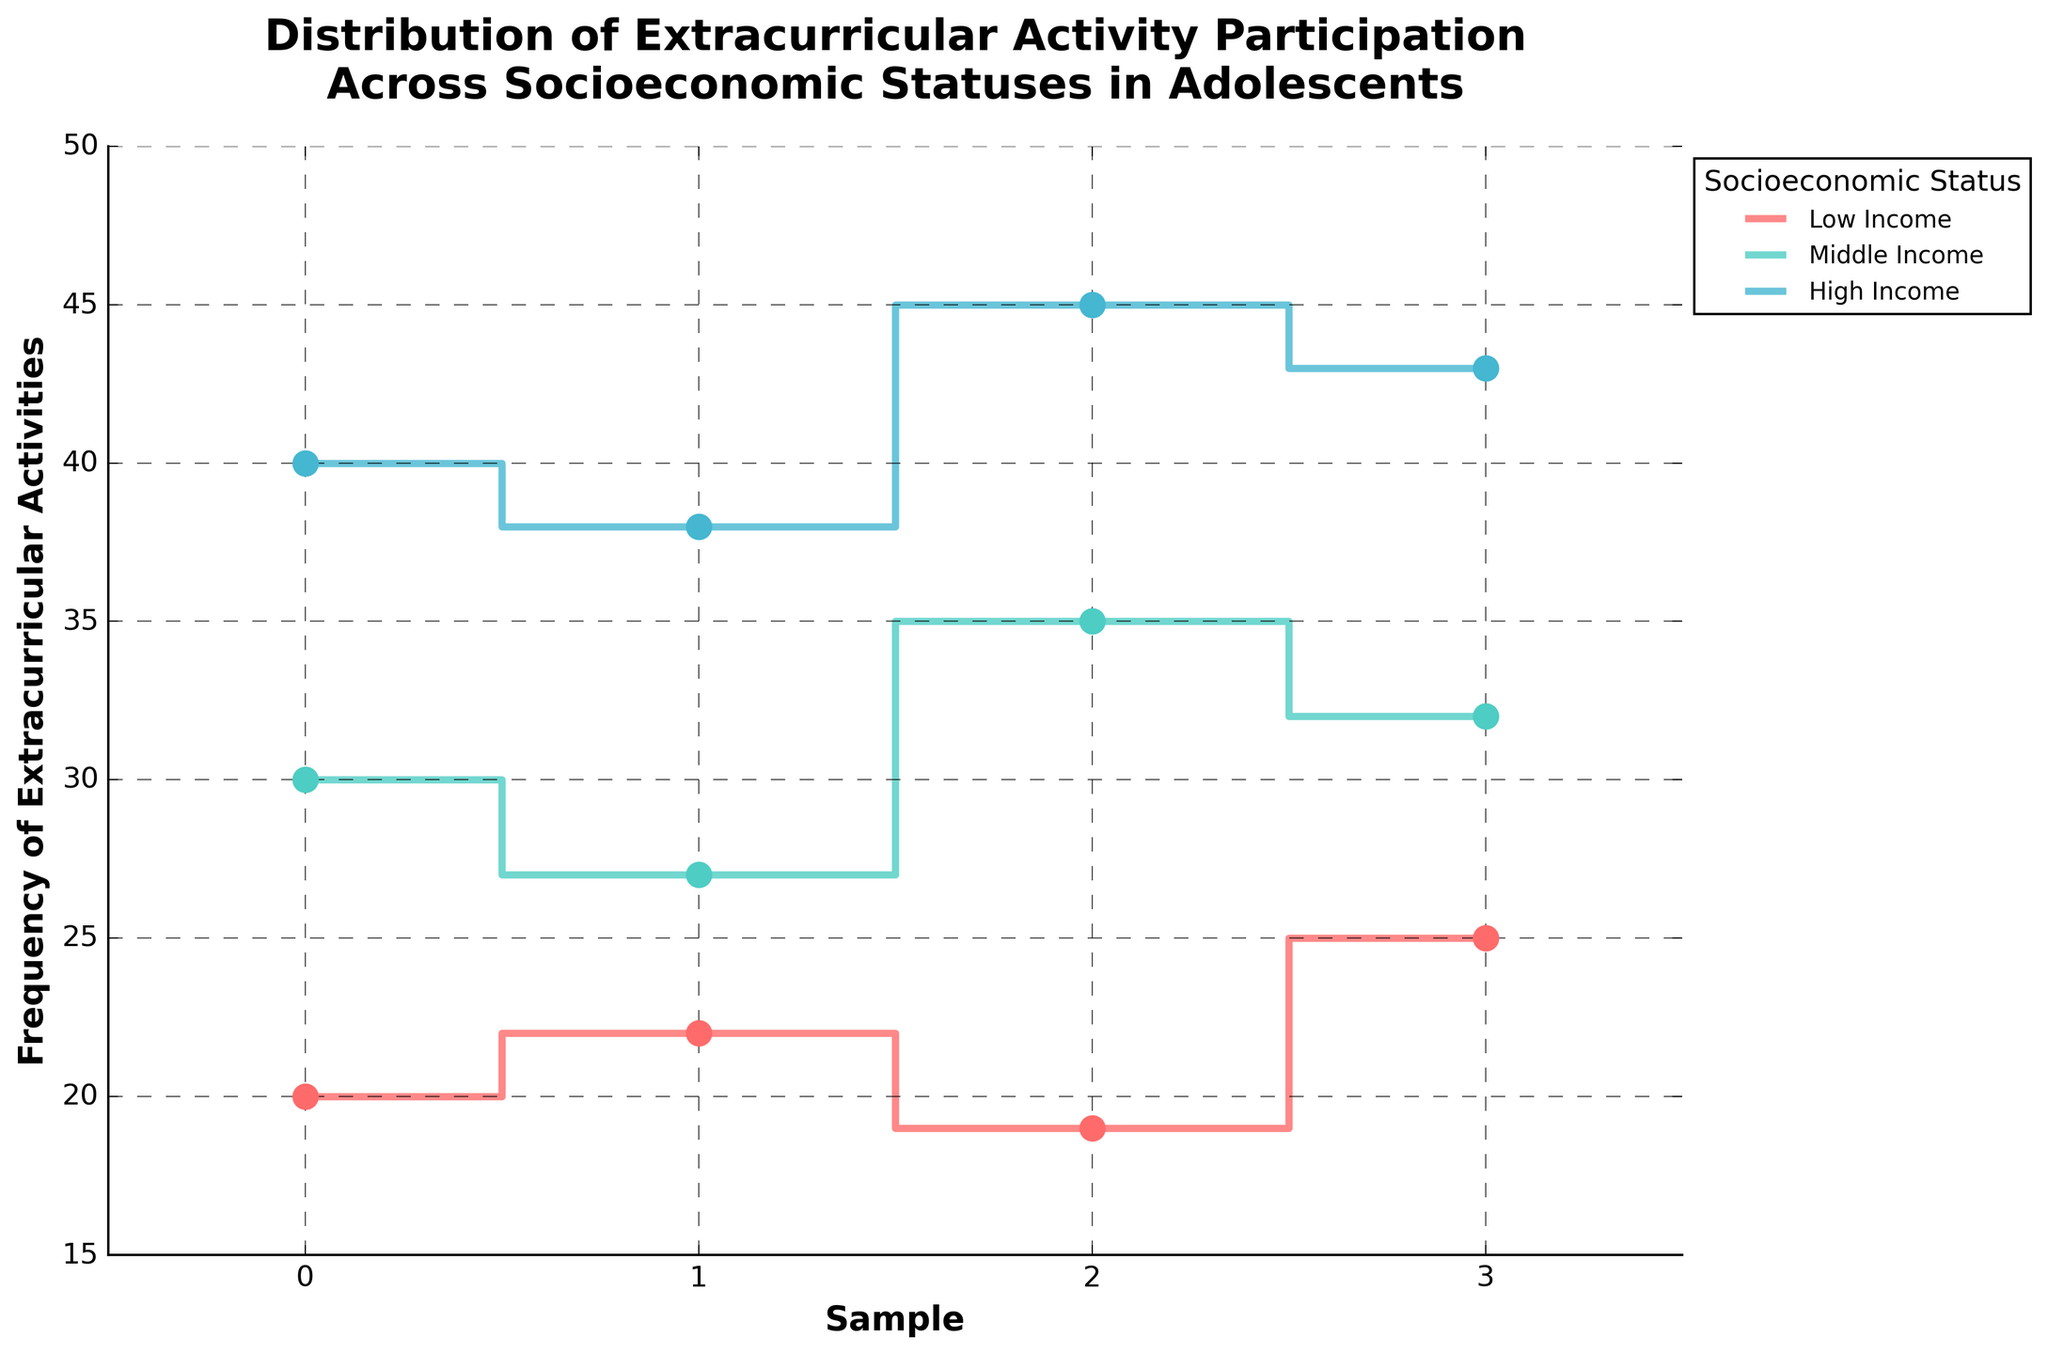What does the title of the figure say? The title of the figure is found at the top and describes the main topic of the figure. It reads "Distribution of Extracurricular Activity Participation Across Socioeconomic Statuses in Adolescents."
Answer: Distribution of Extracurricular Activity Participation Across Socioeconomic Statuses in Adolescents How many socioeconomic groups are depicted in the figure? By looking at the legend or distinct lines, it is clear there are different colors and labels for each group. There are three groups labeled Low Income, Middle Income, and High Income.
Answer: Three Which socioeconomic status has the highest maximum frequency of extracurricular activities? By examining the highest points reached by each stair step plot, the High Income group reaches the highest frequency at 45.
Answer: High Income What is the frequency range for the Middle Income group? By looking at the lowest and highest points of the Middle Income group's stair steps, the frequency ranges from 27 to 35.
Answer: 27 to 35 Compare the average frequencies of extracurricular activities between Low Income and Middle Income groups. First, calculate the average for each group: 
Low Income: (20 + 22 + 19 + 25) / 4 = 21.5 
Middle Income: (30 + 27 + 35 + 32) / 4 = 31
Then compare the two averages.
Answer: Middle Income is higher Which group shows the most variation in the frequency of extracurricular activities? By observing the range (difference between max and min values) for each group: 
Low Income: 25 - 19 = 6 
Middle Income: 35 - 27 = 8 
High Income: 45 - 38 = 7 
The Middle Income group shows the most variation.
Answer: Middle Income What is the total frequency of extracurricular activities for the High Income group? Summing up all the data points for the High Income group: 40 + 38 + 45 + 43 = 166.
Answer: 166 At which sample number does the Low Income group's frequency hit its maximum? By following the Low Income step plot, the highest frequency (25) occurs at sample number 3.
Answer: Sample number 3 Does any socioeconomic group have a consistent frequency of extracurricular activities? By analyzing each stair step plot, none of the socioeconomic groups maintain a consistent (flat) frequency. All the groups show changes across the samples.
Answer: No 